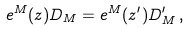Convert formula to latex. <formula><loc_0><loc_0><loc_500><loc_500>e ^ { M } ( z ) D _ { M } = e ^ { M } ( z ^ { \prime } ) D ^ { \prime } _ { M } \, ,</formula> 